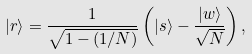Convert formula to latex. <formula><loc_0><loc_0><loc_500><loc_500>| r \rangle = \frac { 1 } { \sqrt { 1 - ( 1 / N ) } } \left ( | s \rangle - \frac { | w \rangle } { \sqrt { N } } \right ) ,</formula> 